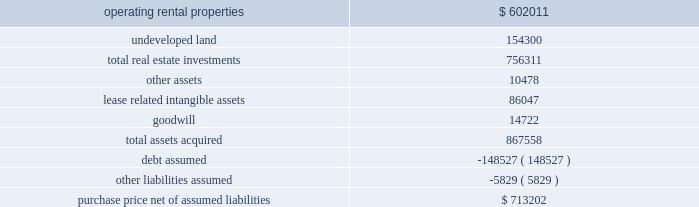As approximately 161 acres of undeveloped land and a 12-acre container storage facility in houston .
The total price was $ 89.7 million and was financed in part through assumption of secured debt that had a fair value of $ 34.3 million .
Of the total purchase price , $ 64.1 million was allocated to in-service real estate assets , $ 20.0 million was allocated to undeveloped land and the container storage facility , $ 5.4 million was allocated to lease related intangible assets , and the remaining amount was allocated to acquired working capital related assets and liabilities .
The results of operations for the acquired properties since the date of acquisition have been included in continuing rental operations in our consolidated financial statements .
In february 2007 , we completed the acquisition of bremner healthcare real estate ( 201cbremner 201d ) , a national health care development and management firm .
The primary reason for the acquisition was to expand our development capabilities within the health care real estate market .
The initial consideration paid to the sellers totaled $ 47.1 million , and the sellers may be eligible for further contingent payments over a three-year period following the acquisition .
Approximately $ 39.0 million of the total purchase price was allocated to goodwill , which is attributable to the value of bremner 2019s overall development capabilities and its in-place workforce .
The results of operations for bremner since the date of acquisition have been included in continuing operations in our consolidated financial statements .
In february 2006 , we acquired the majority of a washington , d.c .
Metropolitan area portfolio of suburban office and light industrial properties ( the 201cmark winkler portfolio 201d ) .
The assets acquired for a purchase price of approximately $ 867.6 million were comprised of 32 in-service properties with approximately 2.9 million square feet for rental , 166 acres of undeveloped land , as well as certain related assets of the mark winkler company , a real estate management company .
The acquisition was financed primarily through assumed mortgage loans and new borrowings .
The assets acquired and liabilities assumed were recorded at their estimated fair value at the date of acquisition , as summarized below ( in thousands ) : .
Purchase price , net of assumed liabilities $ 713202 in december 2006 , we contributed 23 of these in-service properties acquired from the mark winkler portfolio with a basis of $ 381.6 million representing real estate investments and acquired lease related intangible assets to two new unconsolidated subsidiaries .
Of the remaining nine in-service properties , eight were contributed to these two unconsolidated subsidiaries in 2007 and one remains in continuing operations as of december 31 , 2008 .
The eight properties contributed in 2007 had a basis of $ 298.4 million representing real estate investments and acquired lease related intangible assets , and debt secured by these properties of $ 146.4 million was also assumed by the unconsolidated subsidiaries .
In the third quarter of 2006 , we finalized the purchase of a portfolio of industrial real estate properties in savannah , georgia .
We completed a majority of the purchase in january 2006 .
The assets acquired for a purchase price of approximately $ 196.2 million were comprised of 18 buildings with approximately 5.1 million square feet for rental as well as over 60 acres of undeveloped land .
The acquisition was financed in part through assumed mortgage loans .
The results of operations for the acquired properties since the date of acquisition have been included in continuing rental operations in our consolidated financial statements. .
What was the percent of the total assets acquired allocated to undeveloped land? 
Computations: (154300 / 867558)
Answer: 0.17786. 